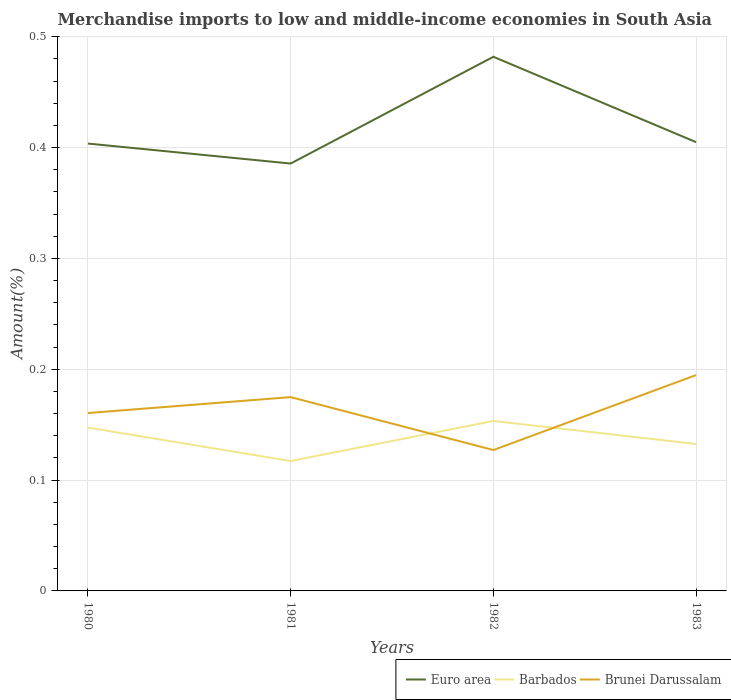Across all years, what is the maximum percentage of amount earned from merchandise imports in Brunei Darussalam?
Keep it short and to the point. 0.13. What is the total percentage of amount earned from merchandise imports in Brunei Darussalam in the graph?
Provide a short and direct response. 0.03. What is the difference between the highest and the second highest percentage of amount earned from merchandise imports in Barbados?
Your response must be concise. 0.04. How many lines are there?
Provide a succinct answer. 3. How many years are there in the graph?
Your response must be concise. 4. What is the difference between two consecutive major ticks on the Y-axis?
Make the answer very short. 0.1. Does the graph contain any zero values?
Make the answer very short. No. Does the graph contain grids?
Offer a terse response. Yes. How many legend labels are there?
Provide a succinct answer. 3. How are the legend labels stacked?
Offer a terse response. Horizontal. What is the title of the graph?
Give a very brief answer. Merchandise imports to low and middle-income economies in South Asia. What is the label or title of the X-axis?
Your answer should be very brief. Years. What is the label or title of the Y-axis?
Offer a very short reply. Amount(%). What is the Amount(%) in Euro area in 1980?
Your answer should be compact. 0.4. What is the Amount(%) of Barbados in 1980?
Make the answer very short. 0.15. What is the Amount(%) of Brunei Darussalam in 1980?
Provide a succinct answer. 0.16. What is the Amount(%) of Euro area in 1981?
Offer a terse response. 0.39. What is the Amount(%) in Barbados in 1981?
Provide a succinct answer. 0.12. What is the Amount(%) of Brunei Darussalam in 1981?
Your answer should be compact. 0.17. What is the Amount(%) in Euro area in 1982?
Your answer should be very brief. 0.48. What is the Amount(%) of Barbados in 1982?
Keep it short and to the point. 0.15. What is the Amount(%) in Brunei Darussalam in 1982?
Offer a very short reply. 0.13. What is the Amount(%) of Euro area in 1983?
Keep it short and to the point. 0.4. What is the Amount(%) of Barbados in 1983?
Ensure brevity in your answer.  0.13. What is the Amount(%) in Brunei Darussalam in 1983?
Your answer should be very brief. 0.19. Across all years, what is the maximum Amount(%) of Euro area?
Ensure brevity in your answer.  0.48. Across all years, what is the maximum Amount(%) in Barbados?
Your answer should be very brief. 0.15. Across all years, what is the maximum Amount(%) in Brunei Darussalam?
Provide a short and direct response. 0.19. Across all years, what is the minimum Amount(%) in Euro area?
Keep it short and to the point. 0.39. Across all years, what is the minimum Amount(%) in Barbados?
Your answer should be compact. 0.12. Across all years, what is the minimum Amount(%) in Brunei Darussalam?
Provide a succinct answer. 0.13. What is the total Amount(%) of Euro area in the graph?
Your response must be concise. 1.68. What is the total Amount(%) in Barbados in the graph?
Provide a succinct answer. 0.55. What is the total Amount(%) in Brunei Darussalam in the graph?
Offer a terse response. 0.66. What is the difference between the Amount(%) in Euro area in 1980 and that in 1981?
Your response must be concise. 0.02. What is the difference between the Amount(%) in Barbados in 1980 and that in 1981?
Give a very brief answer. 0.03. What is the difference between the Amount(%) in Brunei Darussalam in 1980 and that in 1981?
Ensure brevity in your answer.  -0.01. What is the difference between the Amount(%) of Euro area in 1980 and that in 1982?
Offer a very short reply. -0.08. What is the difference between the Amount(%) in Barbados in 1980 and that in 1982?
Offer a terse response. -0.01. What is the difference between the Amount(%) in Brunei Darussalam in 1980 and that in 1982?
Provide a succinct answer. 0.03. What is the difference between the Amount(%) of Euro area in 1980 and that in 1983?
Provide a succinct answer. -0. What is the difference between the Amount(%) in Barbados in 1980 and that in 1983?
Give a very brief answer. 0.01. What is the difference between the Amount(%) in Brunei Darussalam in 1980 and that in 1983?
Make the answer very short. -0.03. What is the difference between the Amount(%) of Euro area in 1981 and that in 1982?
Offer a very short reply. -0.1. What is the difference between the Amount(%) of Barbados in 1981 and that in 1982?
Offer a terse response. -0.04. What is the difference between the Amount(%) in Brunei Darussalam in 1981 and that in 1982?
Your answer should be compact. 0.05. What is the difference between the Amount(%) in Euro area in 1981 and that in 1983?
Provide a short and direct response. -0.02. What is the difference between the Amount(%) of Barbados in 1981 and that in 1983?
Ensure brevity in your answer.  -0.02. What is the difference between the Amount(%) of Brunei Darussalam in 1981 and that in 1983?
Provide a succinct answer. -0.02. What is the difference between the Amount(%) in Euro area in 1982 and that in 1983?
Your response must be concise. 0.08. What is the difference between the Amount(%) of Barbados in 1982 and that in 1983?
Give a very brief answer. 0.02. What is the difference between the Amount(%) of Brunei Darussalam in 1982 and that in 1983?
Provide a short and direct response. -0.07. What is the difference between the Amount(%) of Euro area in 1980 and the Amount(%) of Barbados in 1981?
Make the answer very short. 0.29. What is the difference between the Amount(%) in Euro area in 1980 and the Amount(%) in Brunei Darussalam in 1981?
Keep it short and to the point. 0.23. What is the difference between the Amount(%) in Barbados in 1980 and the Amount(%) in Brunei Darussalam in 1981?
Make the answer very short. -0.03. What is the difference between the Amount(%) of Euro area in 1980 and the Amount(%) of Barbados in 1982?
Your response must be concise. 0.25. What is the difference between the Amount(%) of Euro area in 1980 and the Amount(%) of Brunei Darussalam in 1982?
Make the answer very short. 0.28. What is the difference between the Amount(%) in Barbados in 1980 and the Amount(%) in Brunei Darussalam in 1982?
Offer a very short reply. 0.02. What is the difference between the Amount(%) in Euro area in 1980 and the Amount(%) in Barbados in 1983?
Your answer should be compact. 0.27. What is the difference between the Amount(%) in Euro area in 1980 and the Amount(%) in Brunei Darussalam in 1983?
Offer a terse response. 0.21. What is the difference between the Amount(%) of Barbados in 1980 and the Amount(%) of Brunei Darussalam in 1983?
Make the answer very short. -0.05. What is the difference between the Amount(%) in Euro area in 1981 and the Amount(%) in Barbados in 1982?
Ensure brevity in your answer.  0.23. What is the difference between the Amount(%) in Euro area in 1981 and the Amount(%) in Brunei Darussalam in 1982?
Offer a very short reply. 0.26. What is the difference between the Amount(%) in Barbados in 1981 and the Amount(%) in Brunei Darussalam in 1982?
Offer a terse response. -0.01. What is the difference between the Amount(%) in Euro area in 1981 and the Amount(%) in Barbados in 1983?
Provide a succinct answer. 0.25. What is the difference between the Amount(%) of Euro area in 1981 and the Amount(%) of Brunei Darussalam in 1983?
Keep it short and to the point. 0.19. What is the difference between the Amount(%) in Barbados in 1981 and the Amount(%) in Brunei Darussalam in 1983?
Give a very brief answer. -0.08. What is the difference between the Amount(%) in Euro area in 1982 and the Amount(%) in Barbados in 1983?
Give a very brief answer. 0.35. What is the difference between the Amount(%) in Euro area in 1982 and the Amount(%) in Brunei Darussalam in 1983?
Give a very brief answer. 0.29. What is the difference between the Amount(%) in Barbados in 1982 and the Amount(%) in Brunei Darussalam in 1983?
Your answer should be compact. -0.04. What is the average Amount(%) in Euro area per year?
Provide a succinct answer. 0.42. What is the average Amount(%) in Barbados per year?
Provide a short and direct response. 0.14. What is the average Amount(%) of Brunei Darussalam per year?
Offer a terse response. 0.16. In the year 1980, what is the difference between the Amount(%) in Euro area and Amount(%) in Barbados?
Your answer should be very brief. 0.26. In the year 1980, what is the difference between the Amount(%) of Euro area and Amount(%) of Brunei Darussalam?
Your answer should be very brief. 0.24. In the year 1980, what is the difference between the Amount(%) of Barbados and Amount(%) of Brunei Darussalam?
Provide a succinct answer. -0.01. In the year 1981, what is the difference between the Amount(%) of Euro area and Amount(%) of Barbados?
Offer a very short reply. 0.27. In the year 1981, what is the difference between the Amount(%) in Euro area and Amount(%) in Brunei Darussalam?
Keep it short and to the point. 0.21. In the year 1981, what is the difference between the Amount(%) in Barbados and Amount(%) in Brunei Darussalam?
Make the answer very short. -0.06. In the year 1982, what is the difference between the Amount(%) of Euro area and Amount(%) of Barbados?
Your answer should be very brief. 0.33. In the year 1982, what is the difference between the Amount(%) of Euro area and Amount(%) of Brunei Darussalam?
Offer a very short reply. 0.35. In the year 1982, what is the difference between the Amount(%) of Barbados and Amount(%) of Brunei Darussalam?
Provide a short and direct response. 0.03. In the year 1983, what is the difference between the Amount(%) in Euro area and Amount(%) in Barbados?
Your answer should be very brief. 0.27. In the year 1983, what is the difference between the Amount(%) of Euro area and Amount(%) of Brunei Darussalam?
Offer a very short reply. 0.21. In the year 1983, what is the difference between the Amount(%) in Barbados and Amount(%) in Brunei Darussalam?
Your response must be concise. -0.06. What is the ratio of the Amount(%) of Euro area in 1980 to that in 1981?
Your response must be concise. 1.05. What is the ratio of the Amount(%) of Barbados in 1980 to that in 1981?
Give a very brief answer. 1.26. What is the ratio of the Amount(%) of Brunei Darussalam in 1980 to that in 1981?
Make the answer very short. 0.92. What is the ratio of the Amount(%) of Euro area in 1980 to that in 1982?
Offer a very short reply. 0.84. What is the ratio of the Amount(%) of Barbados in 1980 to that in 1982?
Your answer should be compact. 0.96. What is the ratio of the Amount(%) in Brunei Darussalam in 1980 to that in 1982?
Provide a short and direct response. 1.26. What is the ratio of the Amount(%) in Barbados in 1980 to that in 1983?
Provide a succinct answer. 1.11. What is the ratio of the Amount(%) in Brunei Darussalam in 1980 to that in 1983?
Provide a succinct answer. 0.82. What is the ratio of the Amount(%) in Euro area in 1981 to that in 1982?
Your answer should be very brief. 0.8. What is the ratio of the Amount(%) of Barbados in 1981 to that in 1982?
Ensure brevity in your answer.  0.76. What is the ratio of the Amount(%) in Brunei Darussalam in 1981 to that in 1982?
Provide a succinct answer. 1.38. What is the ratio of the Amount(%) of Euro area in 1981 to that in 1983?
Offer a very short reply. 0.95. What is the ratio of the Amount(%) of Barbados in 1981 to that in 1983?
Keep it short and to the point. 0.88. What is the ratio of the Amount(%) in Brunei Darussalam in 1981 to that in 1983?
Keep it short and to the point. 0.9. What is the ratio of the Amount(%) of Euro area in 1982 to that in 1983?
Ensure brevity in your answer.  1.19. What is the ratio of the Amount(%) of Barbados in 1982 to that in 1983?
Provide a succinct answer. 1.16. What is the ratio of the Amount(%) in Brunei Darussalam in 1982 to that in 1983?
Ensure brevity in your answer.  0.65. What is the difference between the highest and the second highest Amount(%) of Euro area?
Your response must be concise. 0.08. What is the difference between the highest and the second highest Amount(%) in Barbados?
Your response must be concise. 0.01. What is the difference between the highest and the second highest Amount(%) of Brunei Darussalam?
Keep it short and to the point. 0.02. What is the difference between the highest and the lowest Amount(%) in Euro area?
Offer a terse response. 0.1. What is the difference between the highest and the lowest Amount(%) in Barbados?
Offer a terse response. 0.04. What is the difference between the highest and the lowest Amount(%) of Brunei Darussalam?
Provide a succinct answer. 0.07. 